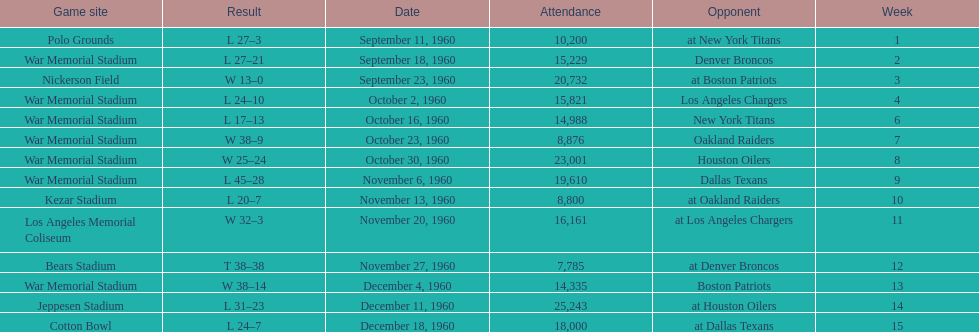What was the largest difference of points in a single game? 29. 